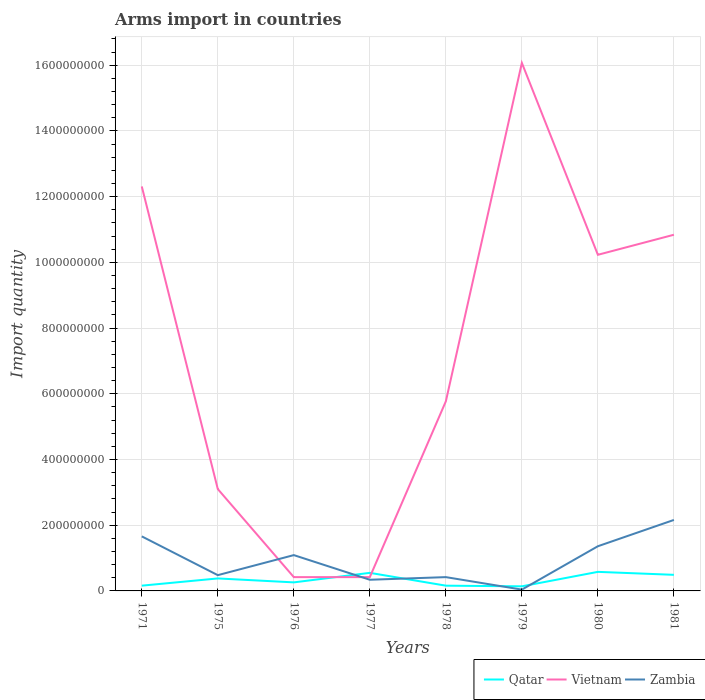In which year was the total arms import in Qatar maximum?
Offer a very short reply. 1979. What is the total total arms import in Zambia in the graph?
Your response must be concise. -1.07e+08. What is the difference between the highest and the second highest total arms import in Vietnam?
Your answer should be compact. 1.56e+09. What is the difference between the highest and the lowest total arms import in Zambia?
Make the answer very short. 4. How many lines are there?
Provide a succinct answer. 3. What is the difference between two consecutive major ticks on the Y-axis?
Make the answer very short. 2.00e+08. Are the values on the major ticks of Y-axis written in scientific E-notation?
Ensure brevity in your answer.  No. Does the graph contain any zero values?
Give a very brief answer. No. Does the graph contain grids?
Your answer should be compact. Yes. How many legend labels are there?
Offer a terse response. 3. What is the title of the graph?
Offer a terse response. Arms import in countries. What is the label or title of the X-axis?
Offer a terse response. Years. What is the label or title of the Y-axis?
Offer a very short reply. Import quantity. What is the Import quantity of Qatar in 1971?
Ensure brevity in your answer.  1.60e+07. What is the Import quantity in Vietnam in 1971?
Provide a succinct answer. 1.23e+09. What is the Import quantity of Zambia in 1971?
Offer a terse response. 1.66e+08. What is the Import quantity of Qatar in 1975?
Your response must be concise. 3.80e+07. What is the Import quantity of Vietnam in 1975?
Provide a short and direct response. 3.10e+08. What is the Import quantity in Zambia in 1975?
Provide a succinct answer. 4.80e+07. What is the Import quantity of Qatar in 1976?
Keep it short and to the point. 2.60e+07. What is the Import quantity of Vietnam in 1976?
Offer a terse response. 4.20e+07. What is the Import quantity in Zambia in 1976?
Your answer should be compact. 1.09e+08. What is the Import quantity in Qatar in 1977?
Make the answer very short. 5.50e+07. What is the Import quantity in Vietnam in 1977?
Give a very brief answer. 4.20e+07. What is the Import quantity of Zambia in 1977?
Make the answer very short. 3.40e+07. What is the Import quantity of Qatar in 1978?
Provide a short and direct response. 1.60e+07. What is the Import quantity of Vietnam in 1978?
Your response must be concise. 5.77e+08. What is the Import quantity in Zambia in 1978?
Keep it short and to the point. 4.20e+07. What is the Import quantity in Qatar in 1979?
Offer a very short reply. 1.40e+07. What is the Import quantity of Vietnam in 1979?
Your response must be concise. 1.61e+09. What is the Import quantity of Zambia in 1979?
Your answer should be compact. 4.00e+06. What is the Import quantity in Qatar in 1980?
Keep it short and to the point. 5.80e+07. What is the Import quantity in Vietnam in 1980?
Your answer should be very brief. 1.02e+09. What is the Import quantity of Zambia in 1980?
Your answer should be very brief. 1.36e+08. What is the Import quantity of Qatar in 1981?
Offer a terse response. 4.90e+07. What is the Import quantity of Vietnam in 1981?
Make the answer very short. 1.08e+09. What is the Import quantity in Zambia in 1981?
Give a very brief answer. 2.16e+08. Across all years, what is the maximum Import quantity of Qatar?
Provide a short and direct response. 5.80e+07. Across all years, what is the maximum Import quantity in Vietnam?
Give a very brief answer. 1.61e+09. Across all years, what is the maximum Import quantity in Zambia?
Give a very brief answer. 2.16e+08. Across all years, what is the minimum Import quantity in Qatar?
Make the answer very short. 1.40e+07. Across all years, what is the minimum Import quantity in Vietnam?
Provide a short and direct response. 4.20e+07. What is the total Import quantity in Qatar in the graph?
Provide a short and direct response. 2.72e+08. What is the total Import quantity of Vietnam in the graph?
Ensure brevity in your answer.  5.92e+09. What is the total Import quantity in Zambia in the graph?
Provide a succinct answer. 7.55e+08. What is the difference between the Import quantity of Qatar in 1971 and that in 1975?
Ensure brevity in your answer.  -2.20e+07. What is the difference between the Import quantity of Vietnam in 1971 and that in 1975?
Keep it short and to the point. 9.21e+08. What is the difference between the Import quantity of Zambia in 1971 and that in 1975?
Ensure brevity in your answer.  1.18e+08. What is the difference between the Import quantity of Qatar in 1971 and that in 1976?
Provide a succinct answer. -1.00e+07. What is the difference between the Import quantity in Vietnam in 1971 and that in 1976?
Make the answer very short. 1.19e+09. What is the difference between the Import quantity of Zambia in 1971 and that in 1976?
Make the answer very short. 5.70e+07. What is the difference between the Import quantity in Qatar in 1971 and that in 1977?
Offer a very short reply. -3.90e+07. What is the difference between the Import quantity of Vietnam in 1971 and that in 1977?
Your answer should be very brief. 1.19e+09. What is the difference between the Import quantity in Zambia in 1971 and that in 1977?
Give a very brief answer. 1.32e+08. What is the difference between the Import quantity in Vietnam in 1971 and that in 1978?
Provide a succinct answer. 6.54e+08. What is the difference between the Import quantity in Zambia in 1971 and that in 1978?
Provide a short and direct response. 1.24e+08. What is the difference between the Import quantity of Qatar in 1971 and that in 1979?
Your response must be concise. 2.00e+06. What is the difference between the Import quantity of Vietnam in 1971 and that in 1979?
Give a very brief answer. -3.76e+08. What is the difference between the Import quantity of Zambia in 1971 and that in 1979?
Make the answer very short. 1.62e+08. What is the difference between the Import quantity of Qatar in 1971 and that in 1980?
Provide a succinct answer. -4.20e+07. What is the difference between the Import quantity of Vietnam in 1971 and that in 1980?
Offer a terse response. 2.08e+08. What is the difference between the Import quantity of Zambia in 1971 and that in 1980?
Offer a terse response. 3.00e+07. What is the difference between the Import quantity of Qatar in 1971 and that in 1981?
Ensure brevity in your answer.  -3.30e+07. What is the difference between the Import quantity in Vietnam in 1971 and that in 1981?
Your answer should be very brief. 1.47e+08. What is the difference between the Import quantity of Zambia in 1971 and that in 1981?
Your answer should be compact. -5.00e+07. What is the difference between the Import quantity of Vietnam in 1975 and that in 1976?
Offer a very short reply. 2.68e+08. What is the difference between the Import quantity of Zambia in 1975 and that in 1976?
Your answer should be compact. -6.10e+07. What is the difference between the Import quantity of Qatar in 1975 and that in 1977?
Ensure brevity in your answer.  -1.70e+07. What is the difference between the Import quantity of Vietnam in 1975 and that in 1977?
Make the answer very short. 2.68e+08. What is the difference between the Import quantity in Zambia in 1975 and that in 1977?
Ensure brevity in your answer.  1.40e+07. What is the difference between the Import quantity in Qatar in 1975 and that in 1978?
Provide a short and direct response. 2.20e+07. What is the difference between the Import quantity of Vietnam in 1975 and that in 1978?
Offer a very short reply. -2.67e+08. What is the difference between the Import quantity of Qatar in 1975 and that in 1979?
Offer a terse response. 2.40e+07. What is the difference between the Import quantity of Vietnam in 1975 and that in 1979?
Make the answer very short. -1.30e+09. What is the difference between the Import quantity of Zambia in 1975 and that in 1979?
Offer a terse response. 4.40e+07. What is the difference between the Import quantity in Qatar in 1975 and that in 1980?
Your answer should be very brief. -2.00e+07. What is the difference between the Import quantity in Vietnam in 1975 and that in 1980?
Keep it short and to the point. -7.13e+08. What is the difference between the Import quantity in Zambia in 1975 and that in 1980?
Ensure brevity in your answer.  -8.80e+07. What is the difference between the Import quantity of Qatar in 1975 and that in 1981?
Offer a terse response. -1.10e+07. What is the difference between the Import quantity of Vietnam in 1975 and that in 1981?
Ensure brevity in your answer.  -7.74e+08. What is the difference between the Import quantity of Zambia in 1975 and that in 1981?
Make the answer very short. -1.68e+08. What is the difference between the Import quantity of Qatar in 1976 and that in 1977?
Your answer should be compact. -2.90e+07. What is the difference between the Import quantity in Vietnam in 1976 and that in 1977?
Make the answer very short. 0. What is the difference between the Import quantity of Zambia in 1976 and that in 1977?
Give a very brief answer. 7.50e+07. What is the difference between the Import quantity in Vietnam in 1976 and that in 1978?
Provide a short and direct response. -5.35e+08. What is the difference between the Import quantity in Zambia in 1976 and that in 1978?
Your answer should be compact. 6.70e+07. What is the difference between the Import quantity in Qatar in 1976 and that in 1979?
Make the answer very short. 1.20e+07. What is the difference between the Import quantity in Vietnam in 1976 and that in 1979?
Offer a very short reply. -1.56e+09. What is the difference between the Import quantity in Zambia in 1976 and that in 1979?
Provide a short and direct response. 1.05e+08. What is the difference between the Import quantity in Qatar in 1976 and that in 1980?
Provide a succinct answer. -3.20e+07. What is the difference between the Import quantity in Vietnam in 1976 and that in 1980?
Ensure brevity in your answer.  -9.81e+08. What is the difference between the Import quantity of Zambia in 1976 and that in 1980?
Provide a succinct answer. -2.70e+07. What is the difference between the Import quantity of Qatar in 1976 and that in 1981?
Your answer should be compact. -2.30e+07. What is the difference between the Import quantity in Vietnam in 1976 and that in 1981?
Your answer should be compact. -1.04e+09. What is the difference between the Import quantity in Zambia in 1976 and that in 1981?
Make the answer very short. -1.07e+08. What is the difference between the Import quantity in Qatar in 1977 and that in 1978?
Provide a succinct answer. 3.90e+07. What is the difference between the Import quantity of Vietnam in 1977 and that in 1978?
Keep it short and to the point. -5.35e+08. What is the difference between the Import quantity in Zambia in 1977 and that in 1978?
Your response must be concise. -8.00e+06. What is the difference between the Import quantity in Qatar in 1977 and that in 1979?
Offer a very short reply. 4.10e+07. What is the difference between the Import quantity of Vietnam in 1977 and that in 1979?
Offer a terse response. -1.56e+09. What is the difference between the Import quantity of Zambia in 1977 and that in 1979?
Give a very brief answer. 3.00e+07. What is the difference between the Import quantity in Vietnam in 1977 and that in 1980?
Keep it short and to the point. -9.81e+08. What is the difference between the Import quantity of Zambia in 1977 and that in 1980?
Provide a succinct answer. -1.02e+08. What is the difference between the Import quantity of Vietnam in 1977 and that in 1981?
Offer a very short reply. -1.04e+09. What is the difference between the Import quantity in Zambia in 1977 and that in 1981?
Keep it short and to the point. -1.82e+08. What is the difference between the Import quantity in Qatar in 1978 and that in 1979?
Provide a succinct answer. 2.00e+06. What is the difference between the Import quantity in Vietnam in 1978 and that in 1979?
Offer a terse response. -1.03e+09. What is the difference between the Import quantity of Zambia in 1978 and that in 1979?
Offer a very short reply. 3.80e+07. What is the difference between the Import quantity of Qatar in 1978 and that in 1980?
Your response must be concise. -4.20e+07. What is the difference between the Import quantity of Vietnam in 1978 and that in 1980?
Your response must be concise. -4.46e+08. What is the difference between the Import quantity of Zambia in 1978 and that in 1980?
Provide a short and direct response. -9.40e+07. What is the difference between the Import quantity in Qatar in 1978 and that in 1981?
Ensure brevity in your answer.  -3.30e+07. What is the difference between the Import quantity of Vietnam in 1978 and that in 1981?
Provide a short and direct response. -5.07e+08. What is the difference between the Import quantity of Zambia in 1978 and that in 1981?
Provide a succinct answer. -1.74e+08. What is the difference between the Import quantity in Qatar in 1979 and that in 1980?
Provide a short and direct response. -4.40e+07. What is the difference between the Import quantity of Vietnam in 1979 and that in 1980?
Your answer should be compact. 5.84e+08. What is the difference between the Import quantity of Zambia in 1979 and that in 1980?
Offer a very short reply. -1.32e+08. What is the difference between the Import quantity of Qatar in 1979 and that in 1981?
Your answer should be very brief. -3.50e+07. What is the difference between the Import quantity of Vietnam in 1979 and that in 1981?
Keep it short and to the point. 5.23e+08. What is the difference between the Import quantity in Zambia in 1979 and that in 1981?
Offer a terse response. -2.12e+08. What is the difference between the Import quantity of Qatar in 1980 and that in 1981?
Offer a very short reply. 9.00e+06. What is the difference between the Import quantity in Vietnam in 1980 and that in 1981?
Your answer should be compact. -6.10e+07. What is the difference between the Import quantity of Zambia in 1980 and that in 1981?
Your answer should be compact. -8.00e+07. What is the difference between the Import quantity in Qatar in 1971 and the Import quantity in Vietnam in 1975?
Ensure brevity in your answer.  -2.94e+08. What is the difference between the Import quantity in Qatar in 1971 and the Import quantity in Zambia in 1975?
Offer a very short reply. -3.20e+07. What is the difference between the Import quantity of Vietnam in 1971 and the Import quantity of Zambia in 1975?
Your answer should be compact. 1.18e+09. What is the difference between the Import quantity of Qatar in 1971 and the Import quantity of Vietnam in 1976?
Your response must be concise. -2.60e+07. What is the difference between the Import quantity in Qatar in 1971 and the Import quantity in Zambia in 1976?
Provide a short and direct response. -9.30e+07. What is the difference between the Import quantity of Vietnam in 1971 and the Import quantity of Zambia in 1976?
Your response must be concise. 1.12e+09. What is the difference between the Import quantity in Qatar in 1971 and the Import quantity in Vietnam in 1977?
Keep it short and to the point. -2.60e+07. What is the difference between the Import quantity of Qatar in 1971 and the Import quantity of Zambia in 1977?
Make the answer very short. -1.80e+07. What is the difference between the Import quantity of Vietnam in 1971 and the Import quantity of Zambia in 1977?
Make the answer very short. 1.20e+09. What is the difference between the Import quantity in Qatar in 1971 and the Import quantity in Vietnam in 1978?
Give a very brief answer. -5.61e+08. What is the difference between the Import quantity in Qatar in 1971 and the Import quantity in Zambia in 1978?
Keep it short and to the point. -2.60e+07. What is the difference between the Import quantity of Vietnam in 1971 and the Import quantity of Zambia in 1978?
Your response must be concise. 1.19e+09. What is the difference between the Import quantity in Qatar in 1971 and the Import quantity in Vietnam in 1979?
Give a very brief answer. -1.59e+09. What is the difference between the Import quantity in Vietnam in 1971 and the Import quantity in Zambia in 1979?
Offer a terse response. 1.23e+09. What is the difference between the Import quantity of Qatar in 1971 and the Import quantity of Vietnam in 1980?
Offer a very short reply. -1.01e+09. What is the difference between the Import quantity of Qatar in 1971 and the Import quantity of Zambia in 1980?
Make the answer very short. -1.20e+08. What is the difference between the Import quantity of Vietnam in 1971 and the Import quantity of Zambia in 1980?
Offer a very short reply. 1.10e+09. What is the difference between the Import quantity in Qatar in 1971 and the Import quantity in Vietnam in 1981?
Keep it short and to the point. -1.07e+09. What is the difference between the Import quantity of Qatar in 1971 and the Import quantity of Zambia in 1981?
Give a very brief answer. -2.00e+08. What is the difference between the Import quantity in Vietnam in 1971 and the Import quantity in Zambia in 1981?
Give a very brief answer. 1.02e+09. What is the difference between the Import quantity of Qatar in 1975 and the Import quantity of Vietnam in 1976?
Offer a very short reply. -4.00e+06. What is the difference between the Import quantity of Qatar in 1975 and the Import quantity of Zambia in 1976?
Your answer should be compact. -7.10e+07. What is the difference between the Import quantity of Vietnam in 1975 and the Import quantity of Zambia in 1976?
Your answer should be very brief. 2.01e+08. What is the difference between the Import quantity in Qatar in 1975 and the Import quantity in Vietnam in 1977?
Ensure brevity in your answer.  -4.00e+06. What is the difference between the Import quantity of Qatar in 1975 and the Import quantity of Zambia in 1977?
Your response must be concise. 4.00e+06. What is the difference between the Import quantity in Vietnam in 1975 and the Import quantity in Zambia in 1977?
Ensure brevity in your answer.  2.76e+08. What is the difference between the Import quantity of Qatar in 1975 and the Import quantity of Vietnam in 1978?
Give a very brief answer. -5.39e+08. What is the difference between the Import quantity of Vietnam in 1975 and the Import quantity of Zambia in 1978?
Provide a succinct answer. 2.68e+08. What is the difference between the Import quantity in Qatar in 1975 and the Import quantity in Vietnam in 1979?
Your response must be concise. -1.57e+09. What is the difference between the Import quantity of Qatar in 1975 and the Import quantity of Zambia in 1979?
Keep it short and to the point. 3.40e+07. What is the difference between the Import quantity of Vietnam in 1975 and the Import quantity of Zambia in 1979?
Provide a short and direct response. 3.06e+08. What is the difference between the Import quantity of Qatar in 1975 and the Import quantity of Vietnam in 1980?
Your answer should be compact. -9.85e+08. What is the difference between the Import quantity in Qatar in 1975 and the Import quantity in Zambia in 1980?
Your response must be concise. -9.80e+07. What is the difference between the Import quantity in Vietnam in 1975 and the Import quantity in Zambia in 1980?
Your answer should be very brief. 1.74e+08. What is the difference between the Import quantity of Qatar in 1975 and the Import quantity of Vietnam in 1981?
Your response must be concise. -1.05e+09. What is the difference between the Import quantity of Qatar in 1975 and the Import quantity of Zambia in 1981?
Offer a very short reply. -1.78e+08. What is the difference between the Import quantity of Vietnam in 1975 and the Import quantity of Zambia in 1981?
Keep it short and to the point. 9.40e+07. What is the difference between the Import quantity in Qatar in 1976 and the Import quantity in Vietnam in 1977?
Offer a terse response. -1.60e+07. What is the difference between the Import quantity of Qatar in 1976 and the Import quantity of Zambia in 1977?
Your answer should be very brief. -8.00e+06. What is the difference between the Import quantity of Qatar in 1976 and the Import quantity of Vietnam in 1978?
Your answer should be very brief. -5.51e+08. What is the difference between the Import quantity in Qatar in 1976 and the Import quantity in Zambia in 1978?
Keep it short and to the point. -1.60e+07. What is the difference between the Import quantity in Qatar in 1976 and the Import quantity in Vietnam in 1979?
Provide a short and direct response. -1.58e+09. What is the difference between the Import quantity in Qatar in 1976 and the Import quantity in Zambia in 1979?
Provide a succinct answer. 2.20e+07. What is the difference between the Import quantity in Vietnam in 1976 and the Import quantity in Zambia in 1979?
Make the answer very short. 3.80e+07. What is the difference between the Import quantity of Qatar in 1976 and the Import quantity of Vietnam in 1980?
Your response must be concise. -9.97e+08. What is the difference between the Import quantity of Qatar in 1976 and the Import quantity of Zambia in 1980?
Provide a short and direct response. -1.10e+08. What is the difference between the Import quantity in Vietnam in 1976 and the Import quantity in Zambia in 1980?
Offer a terse response. -9.40e+07. What is the difference between the Import quantity in Qatar in 1976 and the Import quantity in Vietnam in 1981?
Give a very brief answer. -1.06e+09. What is the difference between the Import quantity in Qatar in 1976 and the Import quantity in Zambia in 1981?
Your answer should be very brief. -1.90e+08. What is the difference between the Import quantity of Vietnam in 1976 and the Import quantity of Zambia in 1981?
Your answer should be compact. -1.74e+08. What is the difference between the Import quantity of Qatar in 1977 and the Import quantity of Vietnam in 1978?
Offer a terse response. -5.22e+08. What is the difference between the Import quantity of Qatar in 1977 and the Import quantity of Zambia in 1978?
Your answer should be compact. 1.30e+07. What is the difference between the Import quantity of Vietnam in 1977 and the Import quantity of Zambia in 1978?
Provide a short and direct response. 0. What is the difference between the Import quantity of Qatar in 1977 and the Import quantity of Vietnam in 1979?
Your response must be concise. -1.55e+09. What is the difference between the Import quantity of Qatar in 1977 and the Import quantity of Zambia in 1979?
Make the answer very short. 5.10e+07. What is the difference between the Import quantity of Vietnam in 1977 and the Import quantity of Zambia in 1979?
Offer a terse response. 3.80e+07. What is the difference between the Import quantity in Qatar in 1977 and the Import quantity in Vietnam in 1980?
Your answer should be very brief. -9.68e+08. What is the difference between the Import quantity in Qatar in 1977 and the Import quantity in Zambia in 1980?
Provide a short and direct response. -8.10e+07. What is the difference between the Import quantity in Vietnam in 1977 and the Import quantity in Zambia in 1980?
Make the answer very short. -9.40e+07. What is the difference between the Import quantity of Qatar in 1977 and the Import quantity of Vietnam in 1981?
Make the answer very short. -1.03e+09. What is the difference between the Import quantity of Qatar in 1977 and the Import quantity of Zambia in 1981?
Give a very brief answer. -1.61e+08. What is the difference between the Import quantity in Vietnam in 1977 and the Import quantity in Zambia in 1981?
Offer a very short reply. -1.74e+08. What is the difference between the Import quantity of Qatar in 1978 and the Import quantity of Vietnam in 1979?
Make the answer very short. -1.59e+09. What is the difference between the Import quantity in Vietnam in 1978 and the Import quantity in Zambia in 1979?
Your answer should be compact. 5.73e+08. What is the difference between the Import quantity in Qatar in 1978 and the Import quantity in Vietnam in 1980?
Make the answer very short. -1.01e+09. What is the difference between the Import quantity of Qatar in 1978 and the Import quantity of Zambia in 1980?
Your response must be concise. -1.20e+08. What is the difference between the Import quantity in Vietnam in 1978 and the Import quantity in Zambia in 1980?
Offer a terse response. 4.41e+08. What is the difference between the Import quantity of Qatar in 1978 and the Import quantity of Vietnam in 1981?
Provide a short and direct response. -1.07e+09. What is the difference between the Import quantity of Qatar in 1978 and the Import quantity of Zambia in 1981?
Make the answer very short. -2.00e+08. What is the difference between the Import quantity of Vietnam in 1978 and the Import quantity of Zambia in 1981?
Keep it short and to the point. 3.61e+08. What is the difference between the Import quantity of Qatar in 1979 and the Import quantity of Vietnam in 1980?
Provide a short and direct response. -1.01e+09. What is the difference between the Import quantity in Qatar in 1979 and the Import quantity in Zambia in 1980?
Your answer should be compact. -1.22e+08. What is the difference between the Import quantity of Vietnam in 1979 and the Import quantity of Zambia in 1980?
Provide a succinct answer. 1.47e+09. What is the difference between the Import quantity of Qatar in 1979 and the Import quantity of Vietnam in 1981?
Provide a succinct answer. -1.07e+09. What is the difference between the Import quantity in Qatar in 1979 and the Import quantity in Zambia in 1981?
Your answer should be very brief. -2.02e+08. What is the difference between the Import quantity in Vietnam in 1979 and the Import quantity in Zambia in 1981?
Keep it short and to the point. 1.39e+09. What is the difference between the Import quantity in Qatar in 1980 and the Import quantity in Vietnam in 1981?
Make the answer very short. -1.03e+09. What is the difference between the Import quantity of Qatar in 1980 and the Import quantity of Zambia in 1981?
Keep it short and to the point. -1.58e+08. What is the difference between the Import quantity in Vietnam in 1980 and the Import quantity in Zambia in 1981?
Your answer should be very brief. 8.07e+08. What is the average Import quantity of Qatar per year?
Provide a short and direct response. 3.40e+07. What is the average Import quantity of Vietnam per year?
Your answer should be very brief. 7.40e+08. What is the average Import quantity of Zambia per year?
Give a very brief answer. 9.44e+07. In the year 1971, what is the difference between the Import quantity of Qatar and Import quantity of Vietnam?
Provide a short and direct response. -1.22e+09. In the year 1971, what is the difference between the Import quantity of Qatar and Import quantity of Zambia?
Ensure brevity in your answer.  -1.50e+08. In the year 1971, what is the difference between the Import quantity in Vietnam and Import quantity in Zambia?
Offer a terse response. 1.06e+09. In the year 1975, what is the difference between the Import quantity in Qatar and Import quantity in Vietnam?
Ensure brevity in your answer.  -2.72e+08. In the year 1975, what is the difference between the Import quantity in Qatar and Import quantity in Zambia?
Give a very brief answer. -1.00e+07. In the year 1975, what is the difference between the Import quantity in Vietnam and Import quantity in Zambia?
Ensure brevity in your answer.  2.62e+08. In the year 1976, what is the difference between the Import quantity of Qatar and Import quantity of Vietnam?
Provide a short and direct response. -1.60e+07. In the year 1976, what is the difference between the Import quantity in Qatar and Import quantity in Zambia?
Your response must be concise. -8.30e+07. In the year 1976, what is the difference between the Import quantity in Vietnam and Import quantity in Zambia?
Your response must be concise. -6.70e+07. In the year 1977, what is the difference between the Import quantity of Qatar and Import quantity of Vietnam?
Offer a terse response. 1.30e+07. In the year 1977, what is the difference between the Import quantity in Qatar and Import quantity in Zambia?
Ensure brevity in your answer.  2.10e+07. In the year 1977, what is the difference between the Import quantity of Vietnam and Import quantity of Zambia?
Ensure brevity in your answer.  8.00e+06. In the year 1978, what is the difference between the Import quantity in Qatar and Import quantity in Vietnam?
Your response must be concise. -5.61e+08. In the year 1978, what is the difference between the Import quantity in Qatar and Import quantity in Zambia?
Provide a short and direct response. -2.60e+07. In the year 1978, what is the difference between the Import quantity of Vietnam and Import quantity of Zambia?
Your answer should be very brief. 5.35e+08. In the year 1979, what is the difference between the Import quantity of Qatar and Import quantity of Vietnam?
Give a very brief answer. -1.59e+09. In the year 1979, what is the difference between the Import quantity in Qatar and Import quantity in Zambia?
Ensure brevity in your answer.  1.00e+07. In the year 1979, what is the difference between the Import quantity in Vietnam and Import quantity in Zambia?
Keep it short and to the point. 1.60e+09. In the year 1980, what is the difference between the Import quantity of Qatar and Import quantity of Vietnam?
Your answer should be very brief. -9.65e+08. In the year 1980, what is the difference between the Import quantity of Qatar and Import quantity of Zambia?
Keep it short and to the point. -7.80e+07. In the year 1980, what is the difference between the Import quantity of Vietnam and Import quantity of Zambia?
Your answer should be compact. 8.87e+08. In the year 1981, what is the difference between the Import quantity of Qatar and Import quantity of Vietnam?
Your answer should be very brief. -1.04e+09. In the year 1981, what is the difference between the Import quantity in Qatar and Import quantity in Zambia?
Provide a short and direct response. -1.67e+08. In the year 1981, what is the difference between the Import quantity in Vietnam and Import quantity in Zambia?
Offer a very short reply. 8.68e+08. What is the ratio of the Import quantity of Qatar in 1971 to that in 1975?
Offer a terse response. 0.42. What is the ratio of the Import quantity in Vietnam in 1971 to that in 1975?
Offer a terse response. 3.97. What is the ratio of the Import quantity in Zambia in 1971 to that in 1975?
Provide a short and direct response. 3.46. What is the ratio of the Import quantity of Qatar in 1971 to that in 1976?
Offer a very short reply. 0.62. What is the ratio of the Import quantity of Vietnam in 1971 to that in 1976?
Ensure brevity in your answer.  29.31. What is the ratio of the Import quantity of Zambia in 1971 to that in 1976?
Your response must be concise. 1.52. What is the ratio of the Import quantity of Qatar in 1971 to that in 1977?
Your answer should be compact. 0.29. What is the ratio of the Import quantity of Vietnam in 1971 to that in 1977?
Offer a terse response. 29.31. What is the ratio of the Import quantity of Zambia in 1971 to that in 1977?
Provide a succinct answer. 4.88. What is the ratio of the Import quantity in Vietnam in 1971 to that in 1978?
Your response must be concise. 2.13. What is the ratio of the Import quantity in Zambia in 1971 to that in 1978?
Keep it short and to the point. 3.95. What is the ratio of the Import quantity in Vietnam in 1971 to that in 1979?
Your answer should be compact. 0.77. What is the ratio of the Import quantity in Zambia in 1971 to that in 1979?
Make the answer very short. 41.5. What is the ratio of the Import quantity in Qatar in 1971 to that in 1980?
Make the answer very short. 0.28. What is the ratio of the Import quantity in Vietnam in 1971 to that in 1980?
Offer a terse response. 1.2. What is the ratio of the Import quantity of Zambia in 1971 to that in 1980?
Give a very brief answer. 1.22. What is the ratio of the Import quantity of Qatar in 1971 to that in 1981?
Keep it short and to the point. 0.33. What is the ratio of the Import quantity of Vietnam in 1971 to that in 1981?
Offer a very short reply. 1.14. What is the ratio of the Import quantity in Zambia in 1971 to that in 1981?
Provide a short and direct response. 0.77. What is the ratio of the Import quantity of Qatar in 1975 to that in 1976?
Provide a short and direct response. 1.46. What is the ratio of the Import quantity of Vietnam in 1975 to that in 1976?
Ensure brevity in your answer.  7.38. What is the ratio of the Import quantity in Zambia in 1975 to that in 1976?
Your response must be concise. 0.44. What is the ratio of the Import quantity of Qatar in 1975 to that in 1977?
Provide a short and direct response. 0.69. What is the ratio of the Import quantity in Vietnam in 1975 to that in 1977?
Keep it short and to the point. 7.38. What is the ratio of the Import quantity in Zambia in 1975 to that in 1977?
Your answer should be very brief. 1.41. What is the ratio of the Import quantity of Qatar in 1975 to that in 1978?
Offer a very short reply. 2.38. What is the ratio of the Import quantity of Vietnam in 1975 to that in 1978?
Offer a very short reply. 0.54. What is the ratio of the Import quantity of Zambia in 1975 to that in 1978?
Provide a short and direct response. 1.14. What is the ratio of the Import quantity of Qatar in 1975 to that in 1979?
Offer a terse response. 2.71. What is the ratio of the Import quantity in Vietnam in 1975 to that in 1979?
Offer a terse response. 0.19. What is the ratio of the Import quantity of Zambia in 1975 to that in 1979?
Offer a terse response. 12. What is the ratio of the Import quantity in Qatar in 1975 to that in 1980?
Provide a succinct answer. 0.66. What is the ratio of the Import quantity of Vietnam in 1975 to that in 1980?
Give a very brief answer. 0.3. What is the ratio of the Import quantity in Zambia in 1975 to that in 1980?
Offer a very short reply. 0.35. What is the ratio of the Import quantity in Qatar in 1975 to that in 1981?
Your answer should be very brief. 0.78. What is the ratio of the Import quantity of Vietnam in 1975 to that in 1981?
Provide a short and direct response. 0.29. What is the ratio of the Import quantity of Zambia in 1975 to that in 1981?
Offer a very short reply. 0.22. What is the ratio of the Import quantity of Qatar in 1976 to that in 1977?
Offer a very short reply. 0.47. What is the ratio of the Import quantity in Zambia in 1976 to that in 1977?
Your answer should be compact. 3.21. What is the ratio of the Import quantity of Qatar in 1976 to that in 1978?
Offer a terse response. 1.62. What is the ratio of the Import quantity in Vietnam in 1976 to that in 1978?
Provide a succinct answer. 0.07. What is the ratio of the Import quantity of Zambia in 1976 to that in 1978?
Offer a terse response. 2.6. What is the ratio of the Import quantity in Qatar in 1976 to that in 1979?
Give a very brief answer. 1.86. What is the ratio of the Import quantity of Vietnam in 1976 to that in 1979?
Your answer should be very brief. 0.03. What is the ratio of the Import quantity of Zambia in 1976 to that in 1979?
Provide a succinct answer. 27.25. What is the ratio of the Import quantity of Qatar in 1976 to that in 1980?
Your answer should be compact. 0.45. What is the ratio of the Import quantity of Vietnam in 1976 to that in 1980?
Your answer should be very brief. 0.04. What is the ratio of the Import quantity in Zambia in 1976 to that in 1980?
Offer a terse response. 0.8. What is the ratio of the Import quantity of Qatar in 1976 to that in 1981?
Keep it short and to the point. 0.53. What is the ratio of the Import quantity of Vietnam in 1976 to that in 1981?
Ensure brevity in your answer.  0.04. What is the ratio of the Import quantity in Zambia in 1976 to that in 1981?
Your response must be concise. 0.5. What is the ratio of the Import quantity in Qatar in 1977 to that in 1978?
Provide a short and direct response. 3.44. What is the ratio of the Import quantity of Vietnam in 1977 to that in 1978?
Your response must be concise. 0.07. What is the ratio of the Import quantity of Zambia in 1977 to that in 1978?
Provide a succinct answer. 0.81. What is the ratio of the Import quantity of Qatar in 1977 to that in 1979?
Offer a very short reply. 3.93. What is the ratio of the Import quantity of Vietnam in 1977 to that in 1979?
Your response must be concise. 0.03. What is the ratio of the Import quantity of Zambia in 1977 to that in 1979?
Give a very brief answer. 8.5. What is the ratio of the Import quantity of Qatar in 1977 to that in 1980?
Your answer should be very brief. 0.95. What is the ratio of the Import quantity of Vietnam in 1977 to that in 1980?
Your response must be concise. 0.04. What is the ratio of the Import quantity of Zambia in 1977 to that in 1980?
Make the answer very short. 0.25. What is the ratio of the Import quantity of Qatar in 1977 to that in 1981?
Ensure brevity in your answer.  1.12. What is the ratio of the Import quantity in Vietnam in 1977 to that in 1981?
Your answer should be compact. 0.04. What is the ratio of the Import quantity in Zambia in 1977 to that in 1981?
Ensure brevity in your answer.  0.16. What is the ratio of the Import quantity of Qatar in 1978 to that in 1979?
Offer a terse response. 1.14. What is the ratio of the Import quantity in Vietnam in 1978 to that in 1979?
Your response must be concise. 0.36. What is the ratio of the Import quantity of Zambia in 1978 to that in 1979?
Keep it short and to the point. 10.5. What is the ratio of the Import quantity of Qatar in 1978 to that in 1980?
Your response must be concise. 0.28. What is the ratio of the Import quantity in Vietnam in 1978 to that in 1980?
Give a very brief answer. 0.56. What is the ratio of the Import quantity of Zambia in 1978 to that in 1980?
Your answer should be compact. 0.31. What is the ratio of the Import quantity in Qatar in 1978 to that in 1981?
Your answer should be very brief. 0.33. What is the ratio of the Import quantity of Vietnam in 1978 to that in 1981?
Make the answer very short. 0.53. What is the ratio of the Import quantity of Zambia in 1978 to that in 1981?
Provide a succinct answer. 0.19. What is the ratio of the Import quantity of Qatar in 1979 to that in 1980?
Make the answer very short. 0.24. What is the ratio of the Import quantity in Vietnam in 1979 to that in 1980?
Keep it short and to the point. 1.57. What is the ratio of the Import quantity of Zambia in 1979 to that in 1980?
Ensure brevity in your answer.  0.03. What is the ratio of the Import quantity of Qatar in 1979 to that in 1981?
Your answer should be compact. 0.29. What is the ratio of the Import quantity in Vietnam in 1979 to that in 1981?
Provide a short and direct response. 1.48. What is the ratio of the Import quantity of Zambia in 1979 to that in 1981?
Keep it short and to the point. 0.02. What is the ratio of the Import quantity in Qatar in 1980 to that in 1981?
Make the answer very short. 1.18. What is the ratio of the Import quantity of Vietnam in 1980 to that in 1981?
Provide a short and direct response. 0.94. What is the ratio of the Import quantity of Zambia in 1980 to that in 1981?
Your answer should be compact. 0.63. What is the difference between the highest and the second highest Import quantity of Qatar?
Offer a terse response. 3.00e+06. What is the difference between the highest and the second highest Import quantity in Vietnam?
Your response must be concise. 3.76e+08. What is the difference between the highest and the lowest Import quantity in Qatar?
Your answer should be compact. 4.40e+07. What is the difference between the highest and the lowest Import quantity in Vietnam?
Provide a short and direct response. 1.56e+09. What is the difference between the highest and the lowest Import quantity in Zambia?
Your answer should be very brief. 2.12e+08. 